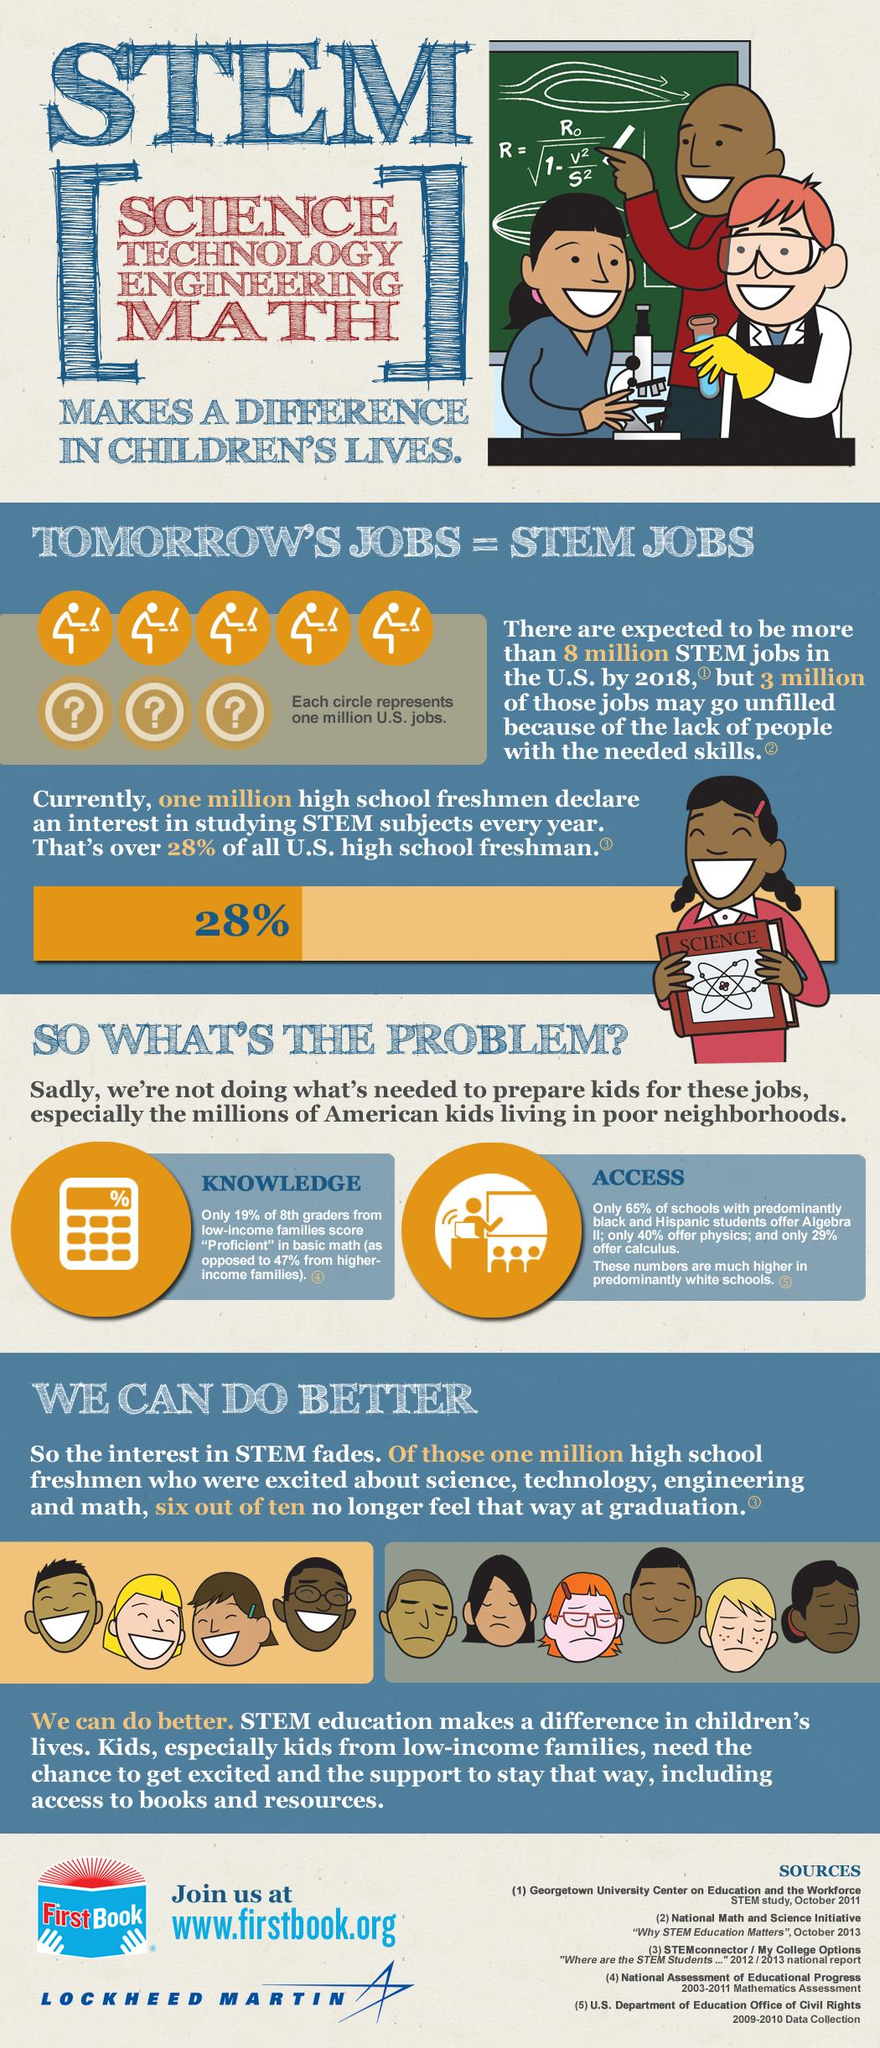Indicate a few pertinent items in this graphic. A recent study has found that only 29% of schools with predominantly black and Hispanic students offer calculus. In STEM, E stands for engineering. Out of ten high school freshmen, four remain excited about STEM subjects. 